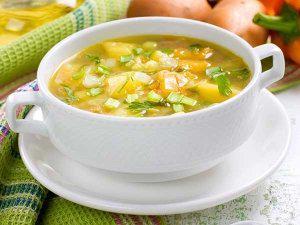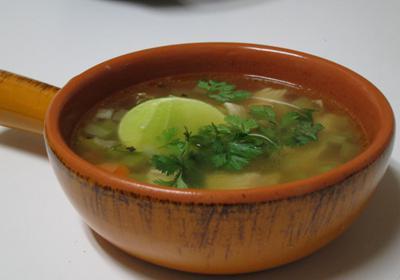The first image is the image on the left, the second image is the image on the right. Given the left and right images, does the statement "A silverware spoon is lying on a flat surface nex to a white bowl containing soup." hold true? Answer yes or no. No. The first image is the image on the left, the second image is the image on the right. Examine the images to the left and right. Is the description "A white spoon is sitting in the bowl in one of the images." accurate? Answer yes or no. No. 